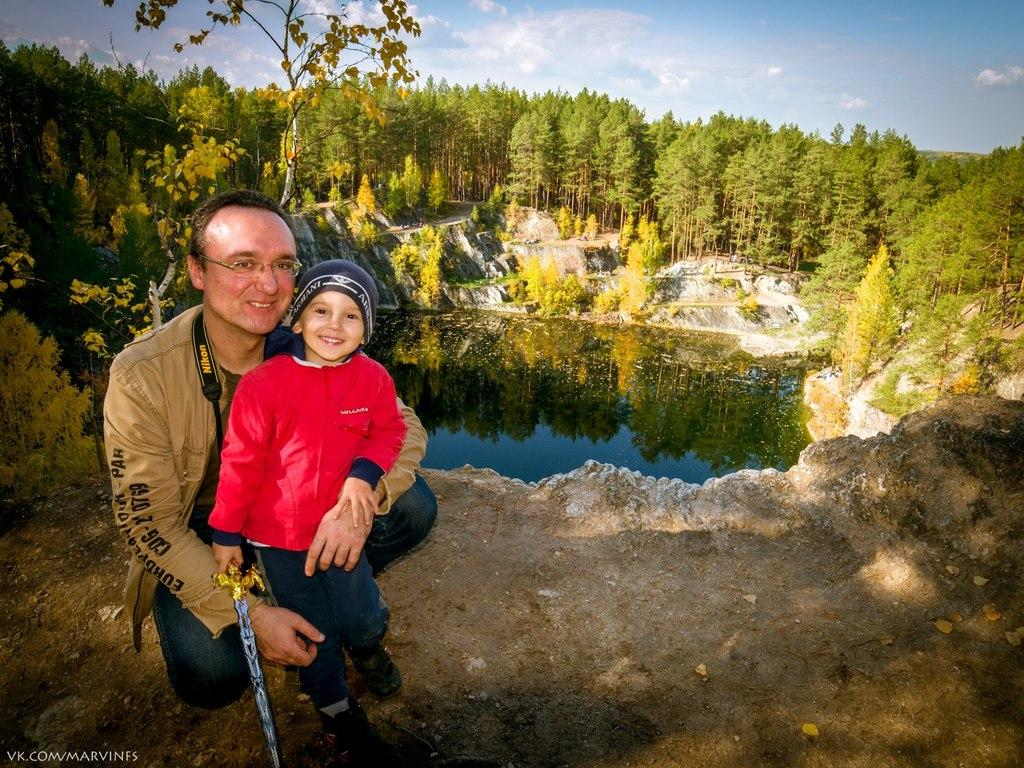Who is the main subject in the front of the image? There is a boy in the front of the image. What is the boy holding in the image? The boy is holding a sword. What can be seen in the background of the image? There are trees, plants, water, and the sky visible in the background of the image. What type of house can be seen in the background of the image? There is no house present in the background of the image. How much blood is visible on the boy's sword in the image? There is no blood visible on the boy's sword in the image. 